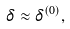Convert formula to latex. <formula><loc_0><loc_0><loc_500><loc_500>\delta \approx \delta ^ { ( 0 ) } ,</formula> 